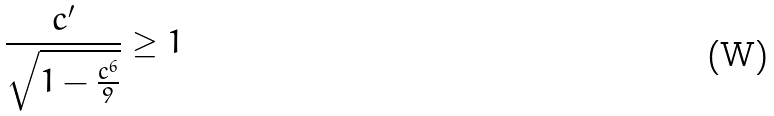Convert formula to latex. <formula><loc_0><loc_0><loc_500><loc_500>\frac { c ^ { \prime } } { \sqrt { 1 - \frac { c ^ { 6 } } { 9 } } } \geq 1</formula> 